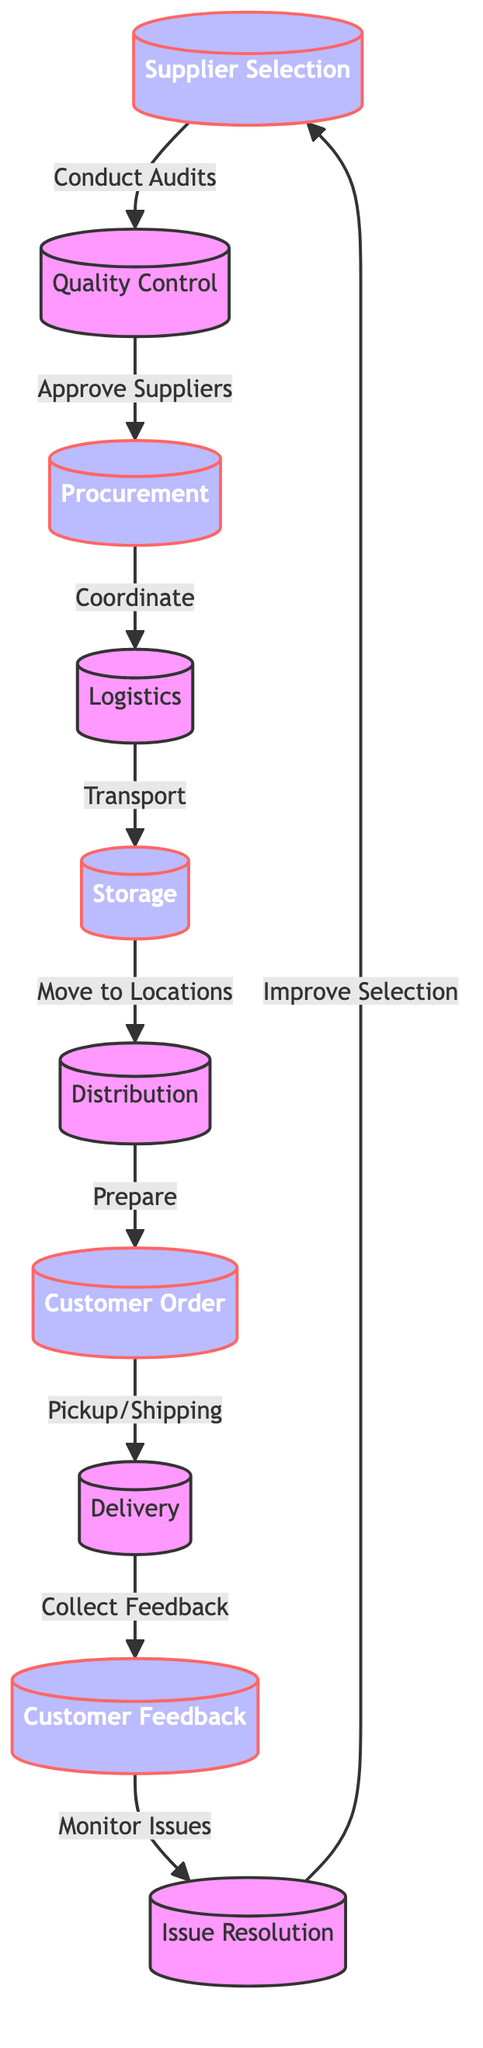What is the first step in the flowchart? The first step is the "Supplier Selection" node, which is the starting point of the entire food supply chain process.
Answer: Supplier Selection How many nodes are present in the diagram? The diagram contains a total of 10 distinct nodes that represent different stages in the food supply chain.
Answer: 10 Which node connects "Storage" to "Distribution"? The node that connects "Storage" to "Distribution" is "Logistics," which involves the transportation of goods from storage to distribution centers.
Answer: Logistics What action is taken from "Customer Feedback"? The action taken from "Customer Feedback" is "Monitor Issues," which indicates the process of observing and addressing any concerns raised by customers.
Answer: Monitor Issues Which two nodes are directly connected by the action "Pickup/Shipping"? The nodes directly connected by the action "Pickup/Shipping" are "Customer Order" and "Delivery," indicating the transition from order fulfillment to delivery completion.
Answer: Customer Order and Delivery How does the flowchart indicate the relationship between "Quality Control" and "Supplier Selection"? The relationship is shown by the arrow from "Supplier Selection" to "Quality Control," indicating that supplier selection involves conducting audits to ensure quality.
Answer: Conduct Audits What step follows "Delivery"? The step that follows "Delivery" is "Collect Feedback," which shows that after deliveries, the feedback from customers is gathered for further evaluation.
Answer: Collect Feedback What is the last node in the flowchart? The last node in the flowchart is "Improve Selection," which indicates an ongoing process to enhance the supplier selection based on the collected feedback and monitored issues.
Answer: Improve Selection Which node is responsible for preparing items before they reach the customers? The node responsible for preparing items before they reach customers is "Distribution," which involves final preparations for item delivery.
Answer: Distribution 